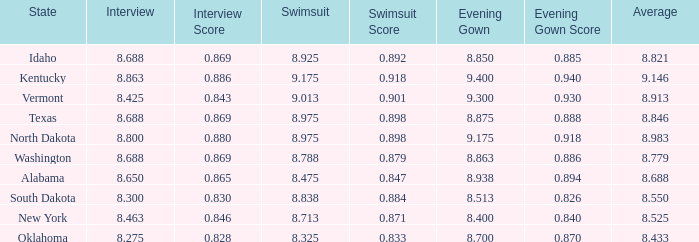What is the average interview score from Kentucky? 8.863. 